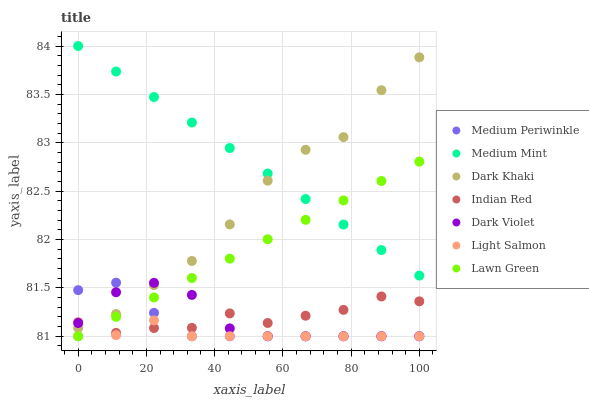Does Light Salmon have the minimum area under the curve?
Answer yes or no. Yes. Does Medium Mint have the maximum area under the curve?
Answer yes or no. Yes. Does Lawn Green have the minimum area under the curve?
Answer yes or no. No. Does Lawn Green have the maximum area under the curve?
Answer yes or no. No. Is Lawn Green the smoothest?
Answer yes or no. Yes. Is Dark Khaki the roughest?
Answer yes or no. Yes. Is Light Salmon the smoothest?
Answer yes or no. No. Is Light Salmon the roughest?
Answer yes or no. No. Does Lawn Green have the lowest value?
Answer yes or no. Yes. Does Dark Khaki have the lowest value?
Answer yes or no. No. Does Medium Mint have the highest value?
Answer yes or no. Yes. Does Lawn Green have the highest value?
Answer yes or no. No. Is Medium Periwinkle less than Medium Mint?
Answer yes or no. Yes. Is Dark Khaki greater than Light Salmon?
Answer yes or no. Yes. Does Lawn Green intersect Medium Periwinkle?
Answer yes or no. Yes. Is Lawn Green less than Medium Periwinkle?
Answer yes or no. No. Is Lawn Green greater than Medium Periwinkle?
Answer yes or no. No. Does Medium Periwinkle intersect Medium Mint?
Answer yes or no. No. 